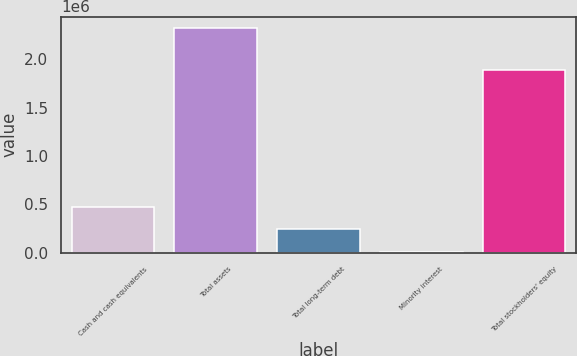Convert chart to OTSL. <chart><loc_0><loc_0><loc_500><loc_500><bar_chart><fcel>Cash and cash equivalents<fcel>Total assets<fcel>Total long-term debt<fcel>Minority interest<fcel>Total stockholders' equity<nl><fcel>475121<fcel>2.32708e+06<fcel>243626<fcel>12130<fcel>1.8908e+06<nl></chart> 